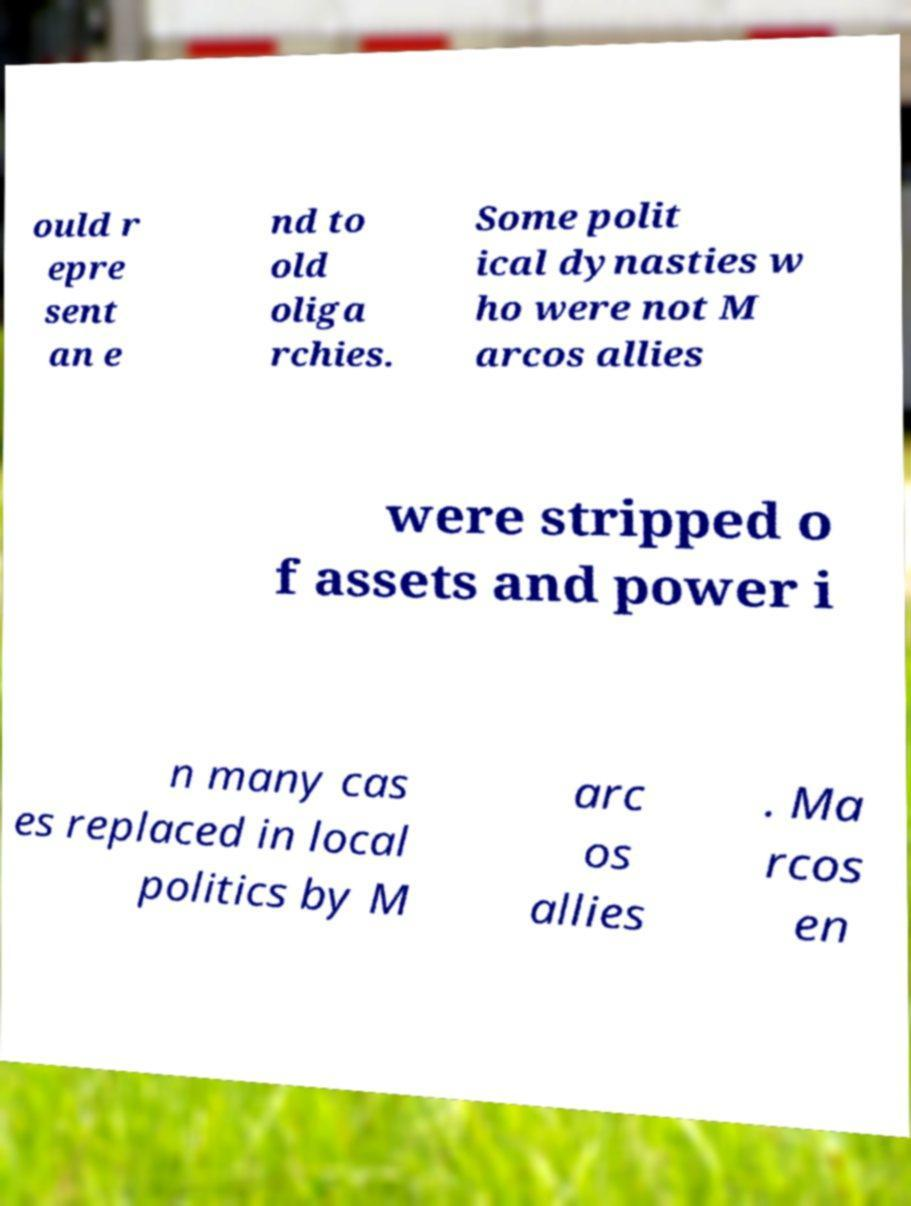Could you assist in decoding the text presented in this image and type it out clearly? ould r epre sent an e nd to old oliga rchies. Some polit ical dynasties w ho were not M arcos allies were stripped o f assets and power i n many cas es replaced in local politics by M arc os allies . Ma rcos en 